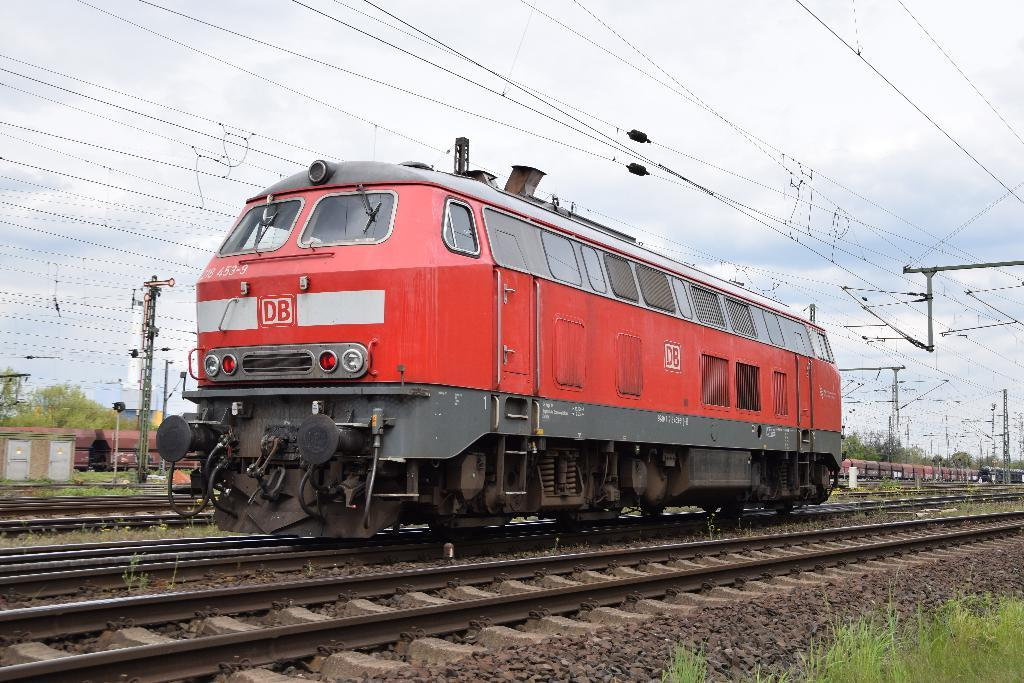What can be seen traveling on the railway tracks in the image? There are trains on the railway tracks in the image. What structures are present alongside the railway tracks? There are current poles in the image. What is connected to the current poles? There are wires in the image. What type of vegetation is visible in the image? There are trees and green grass in the image. What type of ground surface is present in the image? There are small stones in the image. What is the color of the sky in the image? The sky is in white and blue color in the image. Where can the poison be found in the image? There is no poison present in the image. What type of net is used to catch the balls in the image? There are no balls or nets present in the image. 